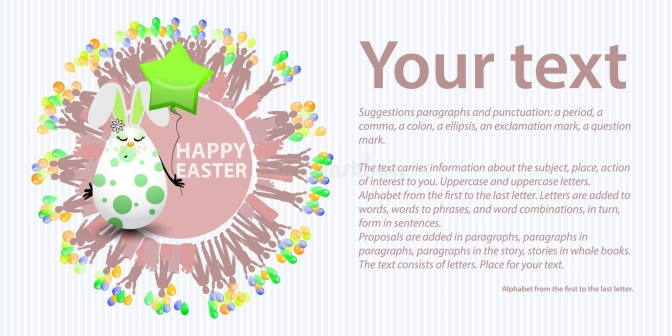Can you draft an invitation text for an Easter event using this image? You're Invited to the Grand Easter Celebration!

Join us for a magical day filled with fun, laughter, and unforgettable moments. Our Easter Bunny, Pip, has prepared a fantastic event just for you! There will be an exciting Easter egg hunt, creative crafts, games, delicious treats, and a dance under the stars.

Date: April 9th
Time: 10 AM - 6 PM
Location: Enchanted Meadow

Bring your family and friends and make this Easter a memorable one! Looking forward to seeing you there! 